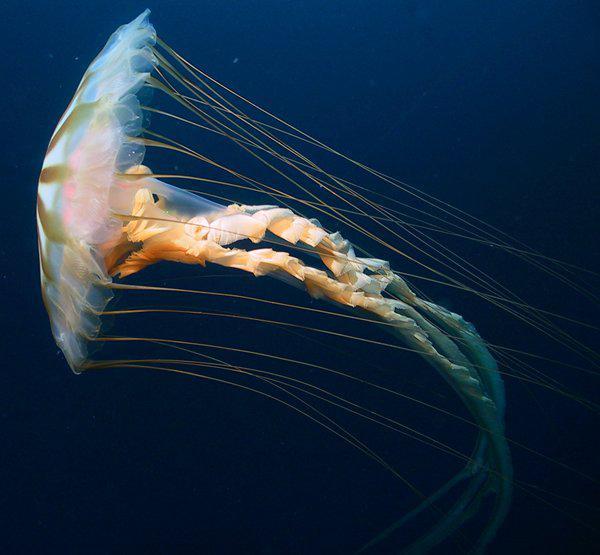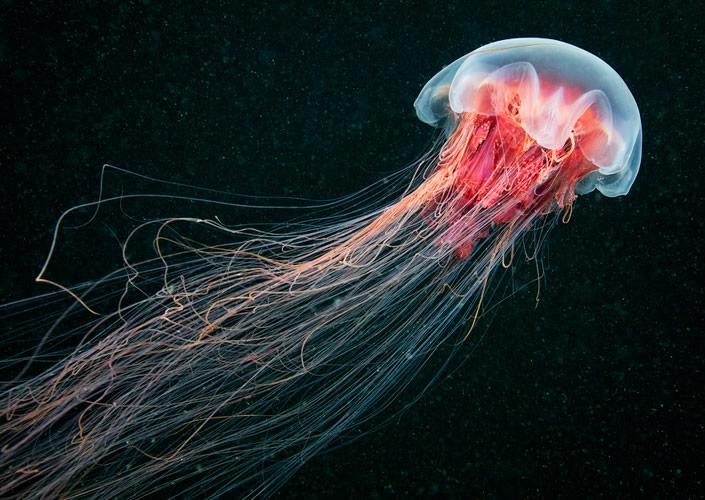The first image is the image on the left, the second image is the image on the right. For the images displayed, is the sentence "Both images show jellyfish with trailing tentacles." factually correct? Answer yes or no. Yes. 